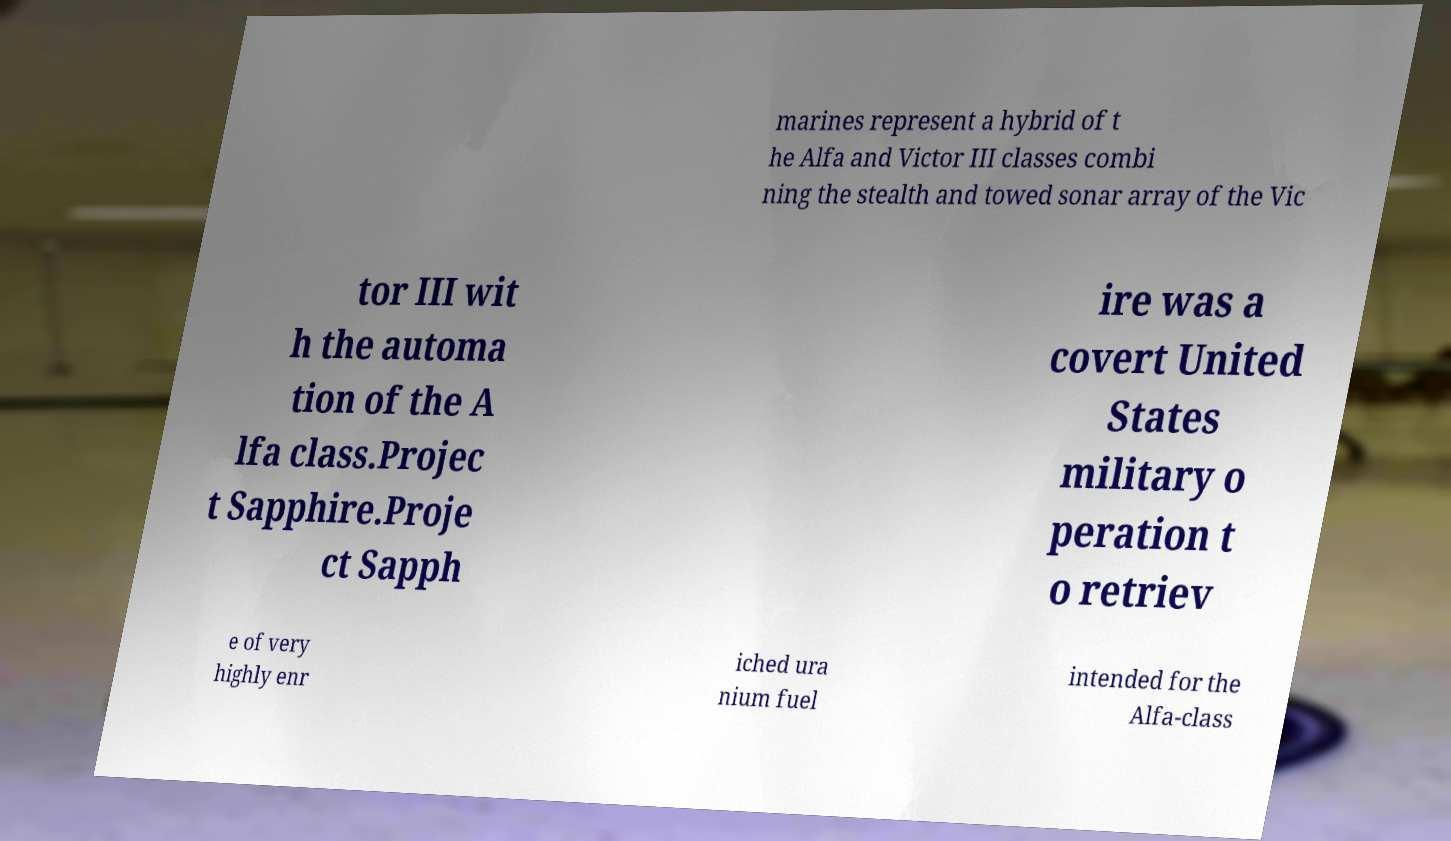What messages or text are displayed in this image? I need them in a readable, typed format. marines represent a hybrid of t he Alfa and Victor III classes combi ning the stealth and towed sonar array of the Vic tor III wit h the automa tion of the A lfa class.Projec t Sapphire.Proje ct Sapph ire was a covert United States military o peration t o retriev e of very highly enr iched ura nium fuel intended for the Alfa-class 